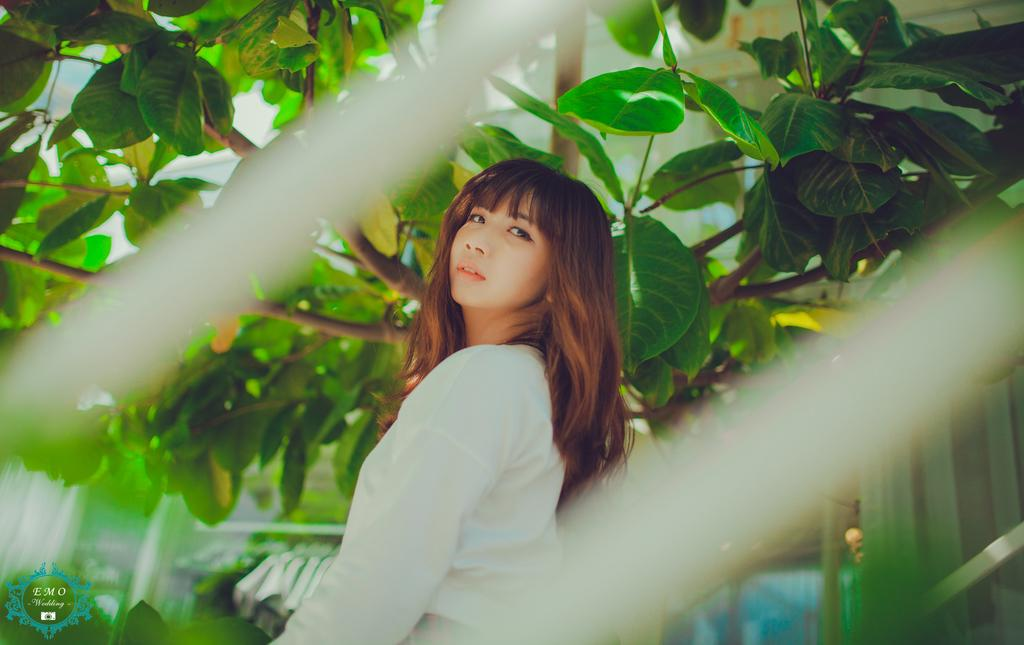What is the main subject of the image? There is a girl standing in the middle of the image. What can be seen in the background of the image? Branches and green leaves are visible in the image. What type of toothbrush is the girl using in the image? There is no toothbrush present in the image. How does the sail affect the girl's position in the image? There is no sail present in the image, so it does not affect the girl's position. 